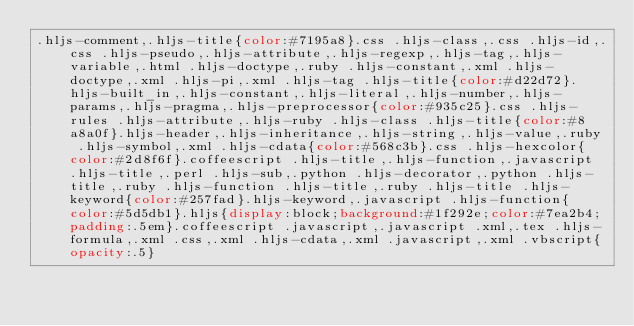<code> <loc_0><loc_0><loc_500><loc_500><_CSS_>.hljs-comment,.hljs-title{color:#7195a8}.css .hljs-class,.css .hljs-id,.css .hljs-pseudo,.hljs-attribute,.hljs-regexp,.hljs-tag,.hljs-variable,.html .hljs-doctype,.ruby .hljs-constant,.xml .hljs-doctype,.xml .hljs-pi,.xml .hljs-tag .hljs-title{color:#d22d72}.hljs-built_in,.hljs-constant,.hljs-literal,.hljs-number,.hljs-params,.hljs-pragma,.hljs-preprocessor{color:#935c25}.css .hljs-rules .hljs-attribute,.hljs-ruby .hljs-class .hljs-title{color:#8a8a0f}.hljs-header,.hljs-inheritance,.hljs-string,.hljs-value,.ruby .hljs-symbol,.xml .hljs-cdata{color:#568c3b}.css .hljs-hexcolor{color:#2d8f6f}.coffeescript .hljs-title,.hljs-function,.javascript .hljs-title,.perl .hljs-sub,.python .hljs-decorator,.python .hljs-title,.ruby .hljs-function .hljs-title,.ruby .hljs-title .hljs-keyword{color:#257fad}.hljs-keyword,.javascript .hljs-function{color:#5d5db1}.hljs{display:block;background:#1f292e;color:#7ea2b4;padding:.5em}.coffeescript .javascript,.javascript .xml,.tex .hljs-formula,.xml .css,.xml .hljs-cdata,.xml .javascript,.xml .vbscript{opacity:.5}</code> 